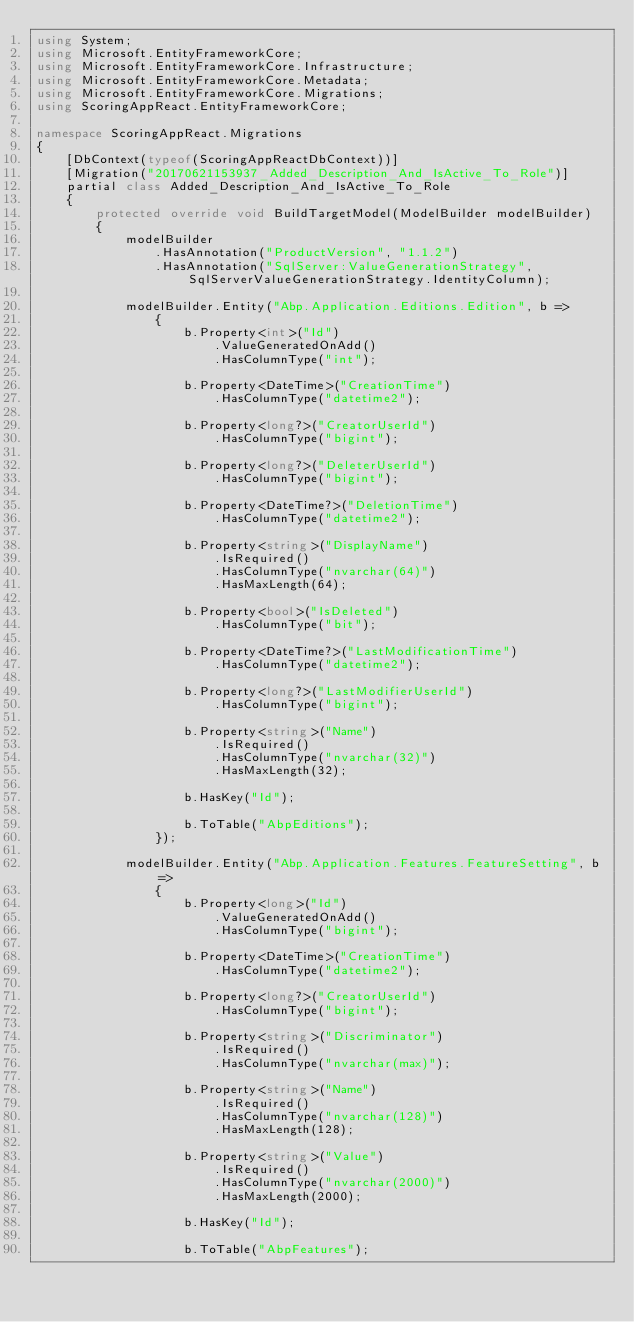<code> <loc_0><loc_0><loc_500><loc_500><_C#_>using System;
using Microsoft.EntityFrameworkCore;
using Microsoft.EntityFrameworkCore.Infrastructure;
using Microsoft.EntityFrameworkCore.Metadata;
using Microsoft.EntityFrameworkCore.Migrations;
using ScoringAppReact.EntityFrameworkCore;

namespace ScoringAppReact.Migrations
{
    [DbContext(typeof(ScoringAppReactDbContext))]
    [Migration("20170621153937_Added_Description_And_IsActive_To_Role")]
    partial class Added_Description_And_IsActive_To_Role
    {
        protected override void BuildTargetModel(ModelBuilder modelBuilder)
        {
            modelBuilder
                .HasAnnotation("ProductVersion", "1.1.2")
                .HasAnnotation("SqlServer:ValueGenerationStrategy", SqlServerValueGenerationStrategy.IdentityColumn);

            modelBuilder.Entity("Abp.Application.Editions.Edition", b =>
                {
                    b.Property<int>("Id")
                        .ValueGeneratedOnAdd()
                        .HasColumnType("int");

                    b.Property<DateTime>("CreationTime")
                        .HasColumnType("datetime2");

                    b.Property<long?>("CreatorUserId")
                        .HasColumnType("bigint");

                    b.Property<long?>("DeleterUserId")
                        .HasColumnType("bigint");

                    b.Property<DateTime?>("DeletionTime")
                        .HasColumnType("datetime2");

                    b.Property<string>("DisplayName")
                        .IsRequired()
                        .HasColumnType("nvarchar(64)")
                        .HasMaxLength(64);

                    b.Property<bool>("IsDeleted")
                        .HasColumnType("bit");

                    b.Property<DateTime?>("LastModificationTime")
                        .HasColumnType("datetime2");

                    b.Property<long?>("LastModifierUserId")
                        .HasColumnType("bigint");

                    b.Property<string>("Name")
                        .IsRequired()
                        .HasColumnType("nvarchar(32)")
                        .HasMaxLength(32);

                    b.HasKey("Id");

                    b.ToTable("AbpEditions");
                });

            modelBuilder.Entity("Abp.Application.Features.FeatureSetting", b =>
                {
                    b.Property<long>("Id")
                        .ValueGeneratedOnAdd()
                        .HasColumnType("bigint");

                    b.Property<DateTime>("CreationTime")
                        .HasColumnType("datetime2");

                    b.Property<long?>("CreatorUserId")
                        .HasColumnType("bigint");

                    b.Property<string>("Discriminator")
                        .IsRequired()
                        .HasColumnType("nvarchar(max)");

                    b.Property<string>("Name")
                        .IsRequired()
                        .HasColumnType("nvarchar(128)")
                        .HasMaxLength(128);

                    b.Property<string>("Value")
                        .IsRequired()
                        .HasColumnType("nvarchar(2000)")
                        .HasMaxLength(2000);

                    b.HasKey("Id");

                    b.ToTable("AbpFeatures");
</code> 